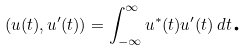Convert formula to latex. <formula><loc_0><loc_0><loc_500><loc_500>( u ( t ) , u ^ { \prime } ( t ) ) = \int _ { - \infty } ^ { \infty } u ^ { * } ( t ) u ^ { \prime } ( t ) \, d t \text {.}</formula> 